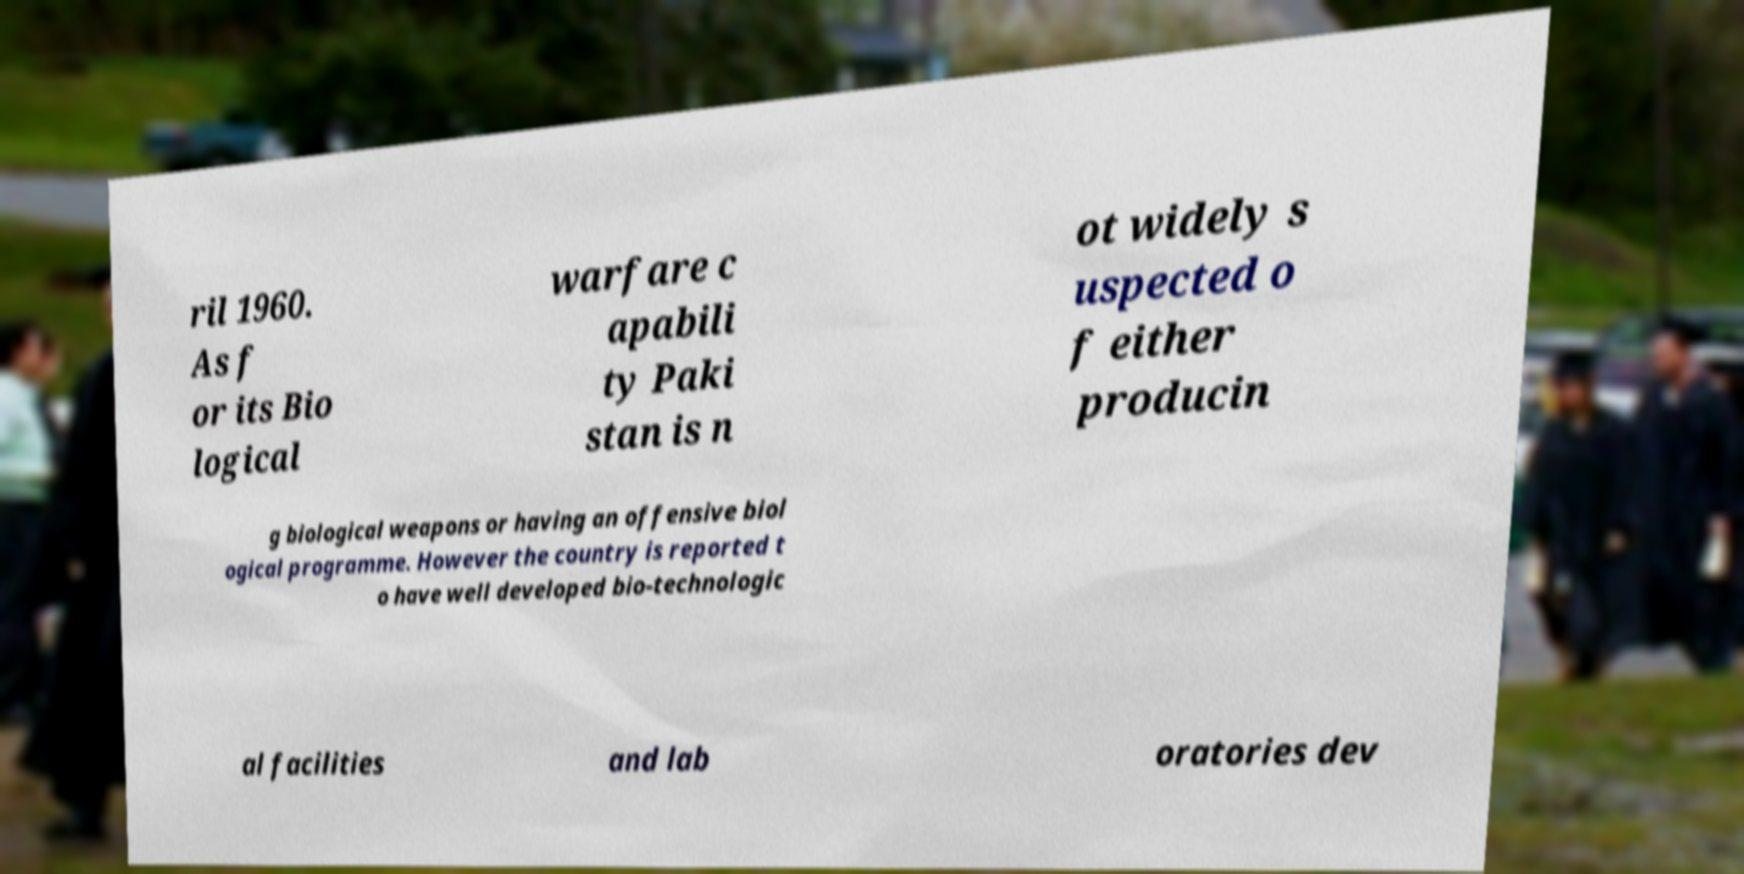Can you accurately transcribe the text from the provided image for me? ril 1960. As f or its Bio logical warfare c apabili ty Paki stan is n ot widely s uspected o f either producin g biological weapons or having an offensive biol ogical programme. However the country is reported t o have well developed bio-technologic al facilities and lab oratories dev 